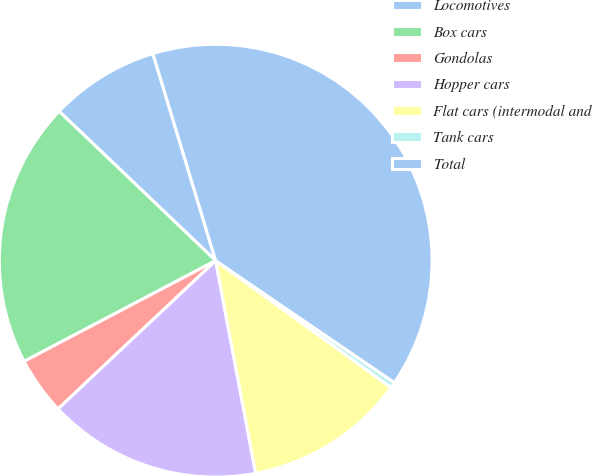Convert chart to OTSL. <chart><loc_0><loc_0><loc_500><loc_500><pie_chart><fcel>Locomotives<fcel>Box cars<fcel>Gondolas<fcel>Hopper cars<fcel>Flat cars (intermodal and<fcel>Tank cars<fcel>Total<nl><fcel>8.19%<fcel>19.83%<fcel>4.31%<fcel>15.95%<fcel>12.07%<fcel>0.44%<fcel>39.21%<nl></chart> 